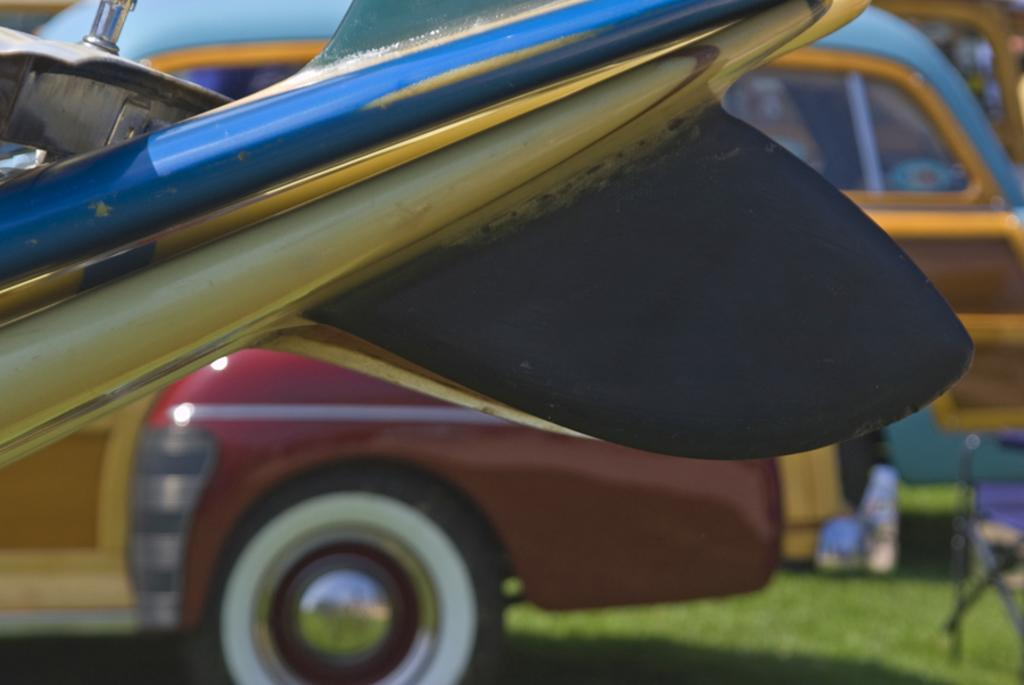What type of vehicles can be seen in the image? There are cars in the image. Can you describe the setting where the chair is placed? The chair is on the grass in the image. Where is the faucet located in the image? There is no faucet present in the image. What type of bait is being used by the cars in the image? There is no bait or fishing activity depicted in the image; it features cars and a chair on the grass. 